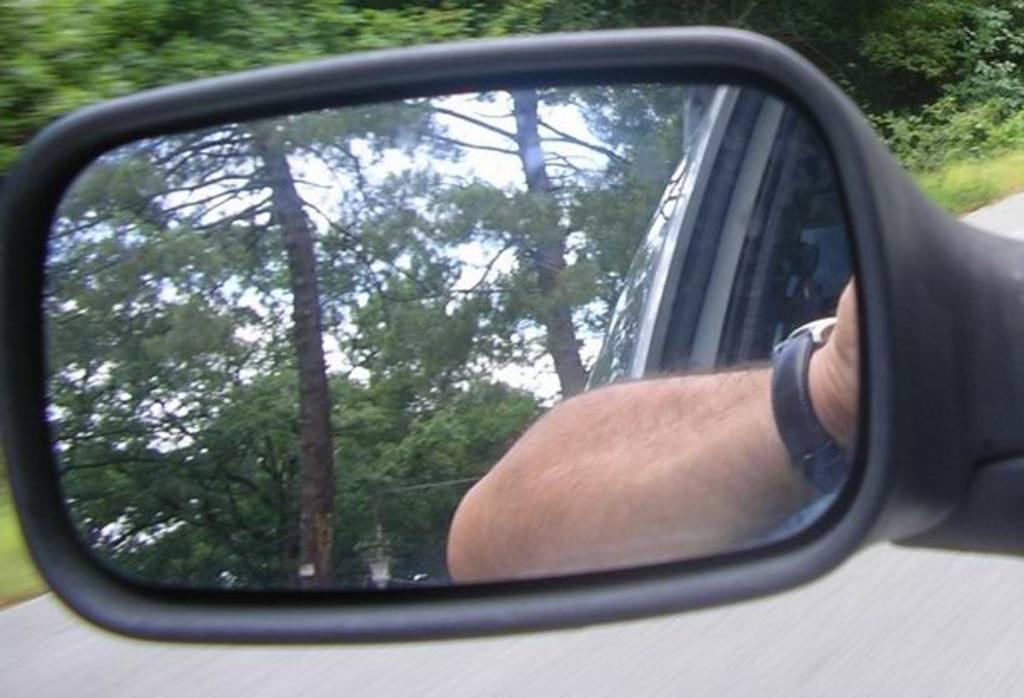Describe this image in one or two sentences. In this image there is a car mirror in that mirror trees and hand of a man is visible, in the background there are trees and a road. 